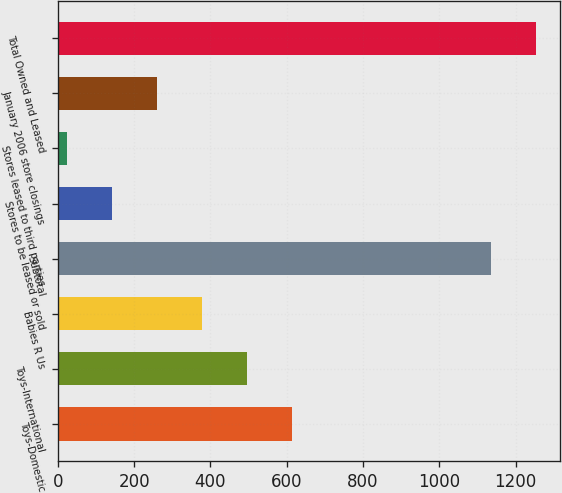Convert chart to OTSL. <chart><loc_0><loc_0><loc_500><loc_500><bar_chart><fcel>Toys-Domestic<fcel>Toys-International<fcel>Babies R Us<fcel>Subtotal<fcel>Stores to be leased or sold<fcel>Stores leased to third parties<fcel>January 2006 store closings<fcel>Total Owned and Leased<nl><fcel>614.5<fcel>496.6<fcel>378.7<fcel>1135<fcel>142.9<fcel>25<fcel>260.8<fcel>1252.9<nl></chart> 